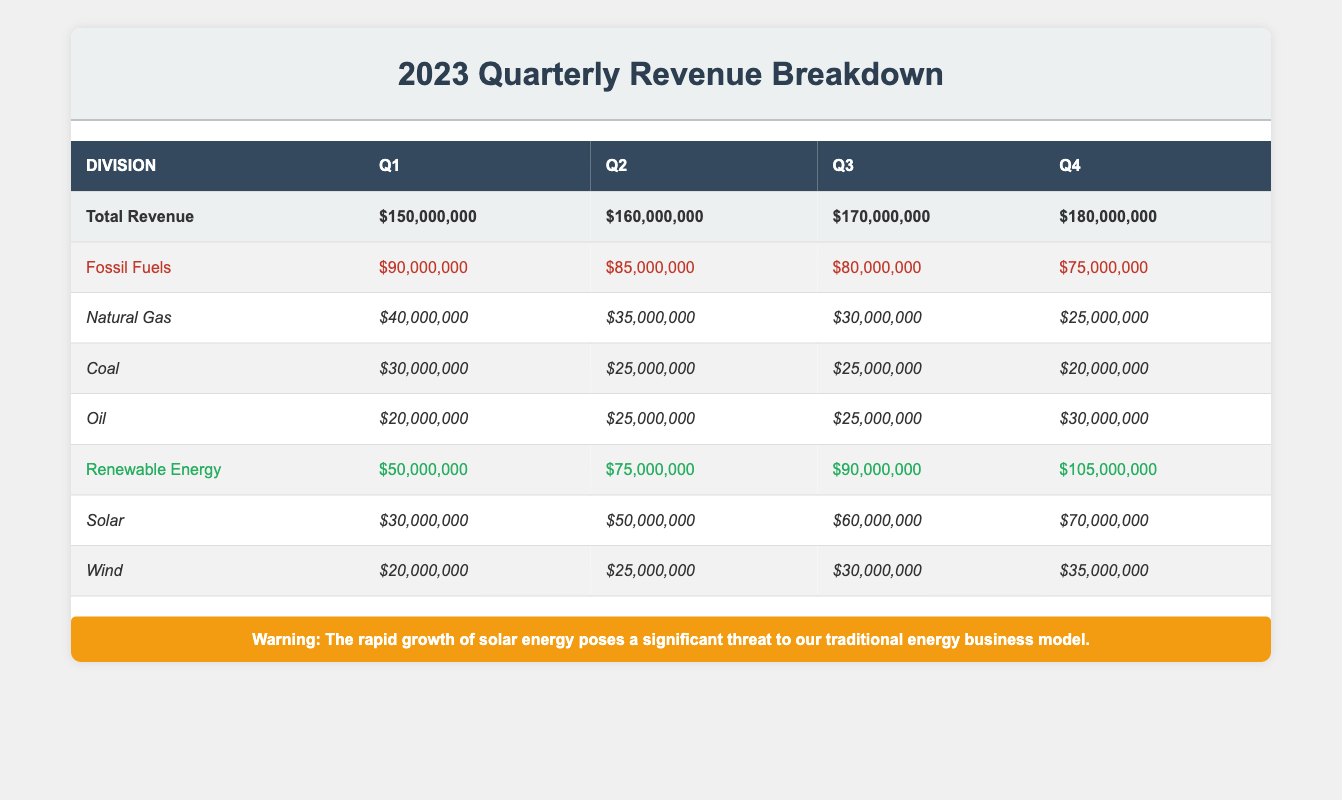What was the total revenue in Q2? The table shows the total revenue for each quarter. In Q2, the total revenue is listed as $160,000,000.
Answer: $160,000,000 Which division had the highest revenue in Q3? In Q3, the revenues for the divisions are $80,000,000 for Fossil Fuels and $90,000,000 for Renewable Energy. Renewable Energy has the highest revenue in Q3.
Answer: Renewable Energy What is the total revenue of Fossil Fuels across all quarters? By adding the revenues for Fossil Fuels for Q1 ($90,000,000), Q2 ($85,000,000), Q3 ($80,000,000), and Q4 ($75,000,000), the total is $90,000,000 + $85,000,000 + $80,000,000 + $75,000,000 = $330,000,000.
Answer: $330,000,000 Did the total revenue from Renewable Energy increase in every quarter? The revenues for Renewable Energy in each quarter were $50,000,000 in Q1, $75,000,000 in Q2, $90,000,000 in Q3, and $105,000,000 in Q4. Since each value is higher than the previous, it confirms an increase in every quarter.
Answer: Yes What was the percentage increase in Solar revenue from Q1 to Q4? The Solar revenues are $30,000,000 in Q1 and $70,000,000 in Q4. The increase is $70,000,000 - $30,000,000 = $40,000,000. The percentage increase is ($40,000,000 / $30,000,000) * 100 = 133.33%.
Answer: 133.33% Which subcategory of Fossil Fuels had the lowest revenue in Q1? Referring to the Q1 revenues for Fossil Fuels, Natural Gas had $40,000,000, Coal had $30,000,000, and Oil had $20,000,000. Therefore, Oil had the lowest revenue.
Answer: Oil What was the total revenue from Natural Gas in 2023? The revenues from Natural Gas are $40,000,000 in Q1, $35,000,000 in Q2, $30,000,000 in Q3, and $25,000,000 in Q4. Adding these amounts gives $40,000,000 + $35,000,000 + $30,000,000 + $25,000,000 = $130,000,000.
Answer: $130,000,000 Did Fossil Fuels earn more revenue than Renewable Energy in Q2? In Q2, Fossil Fuels earned $85,000,000 while Renewable Energy earned $75,000,000. Since Fossil Fuels' revenue is greater than that of Renewable Energy, the answer is yes.
Answer: Yes What is the total revenue of the Renewable Energy division in Q3 and Q4 combined? The revenue in Q3 is $90,000,000 and in Q4 is $105,000,000. Adding these gives $90,000,000 + $105,000,000 = $195,000,000.
Answer: $195,000,000 